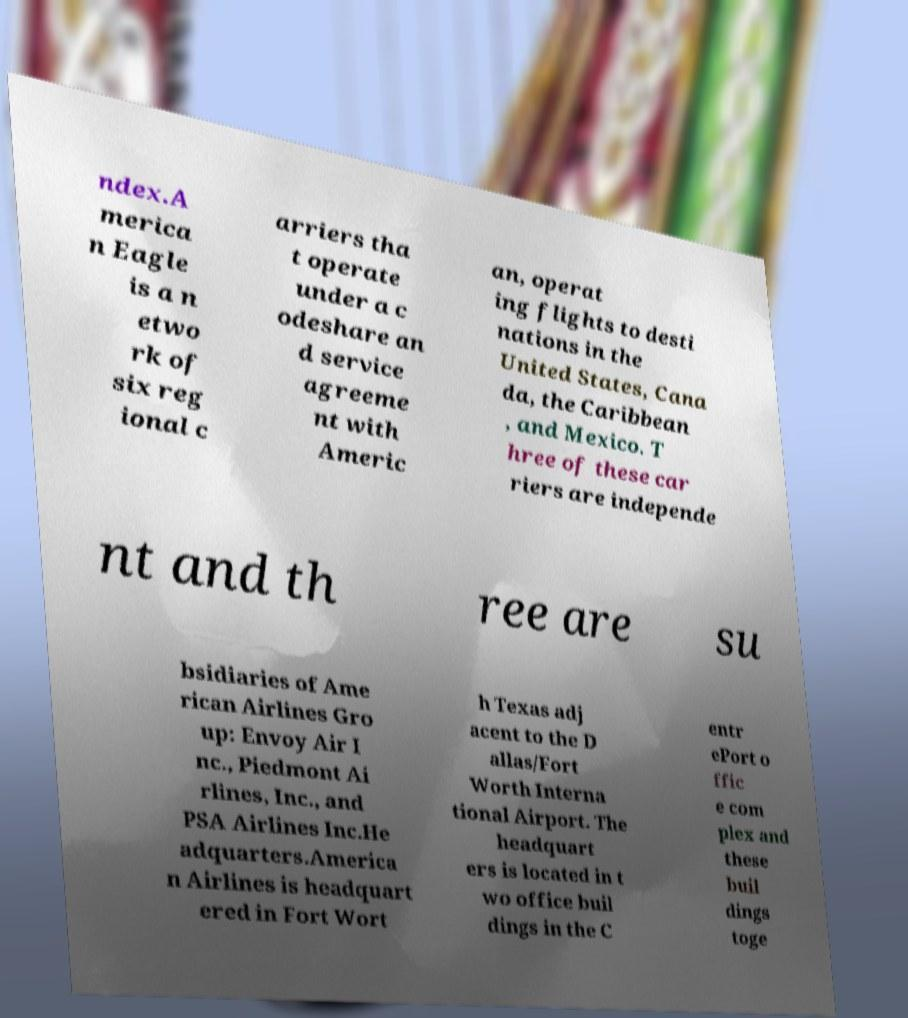What messages or text are displayed in this image? I need them in a readable, typed format. ndex.A merica n Eagle is a n etwo rk of six reg ional c arriers tha t operate under a c odeshare an d service agreeme nt with Americ an, operat ing flights to desti nations in the United States, Cana da, the Caribbean , and Mexico. T hree of these car riers are independe nt and th ree are su bsidiaries of Ame rican Airlines Gro up: Envoy Air I nc., Piedmont Ai rlines, Inc., and PSA Airlines Inc.He adquarters.America n Airlines is headquart ered in Fort Wort h Texas adj acent to the D allas/Fort Worth Interna tional Airport. The headquart ers is located in t wo office buil dings in the C entr ePort o ffic e com plex and these buil dings toge 